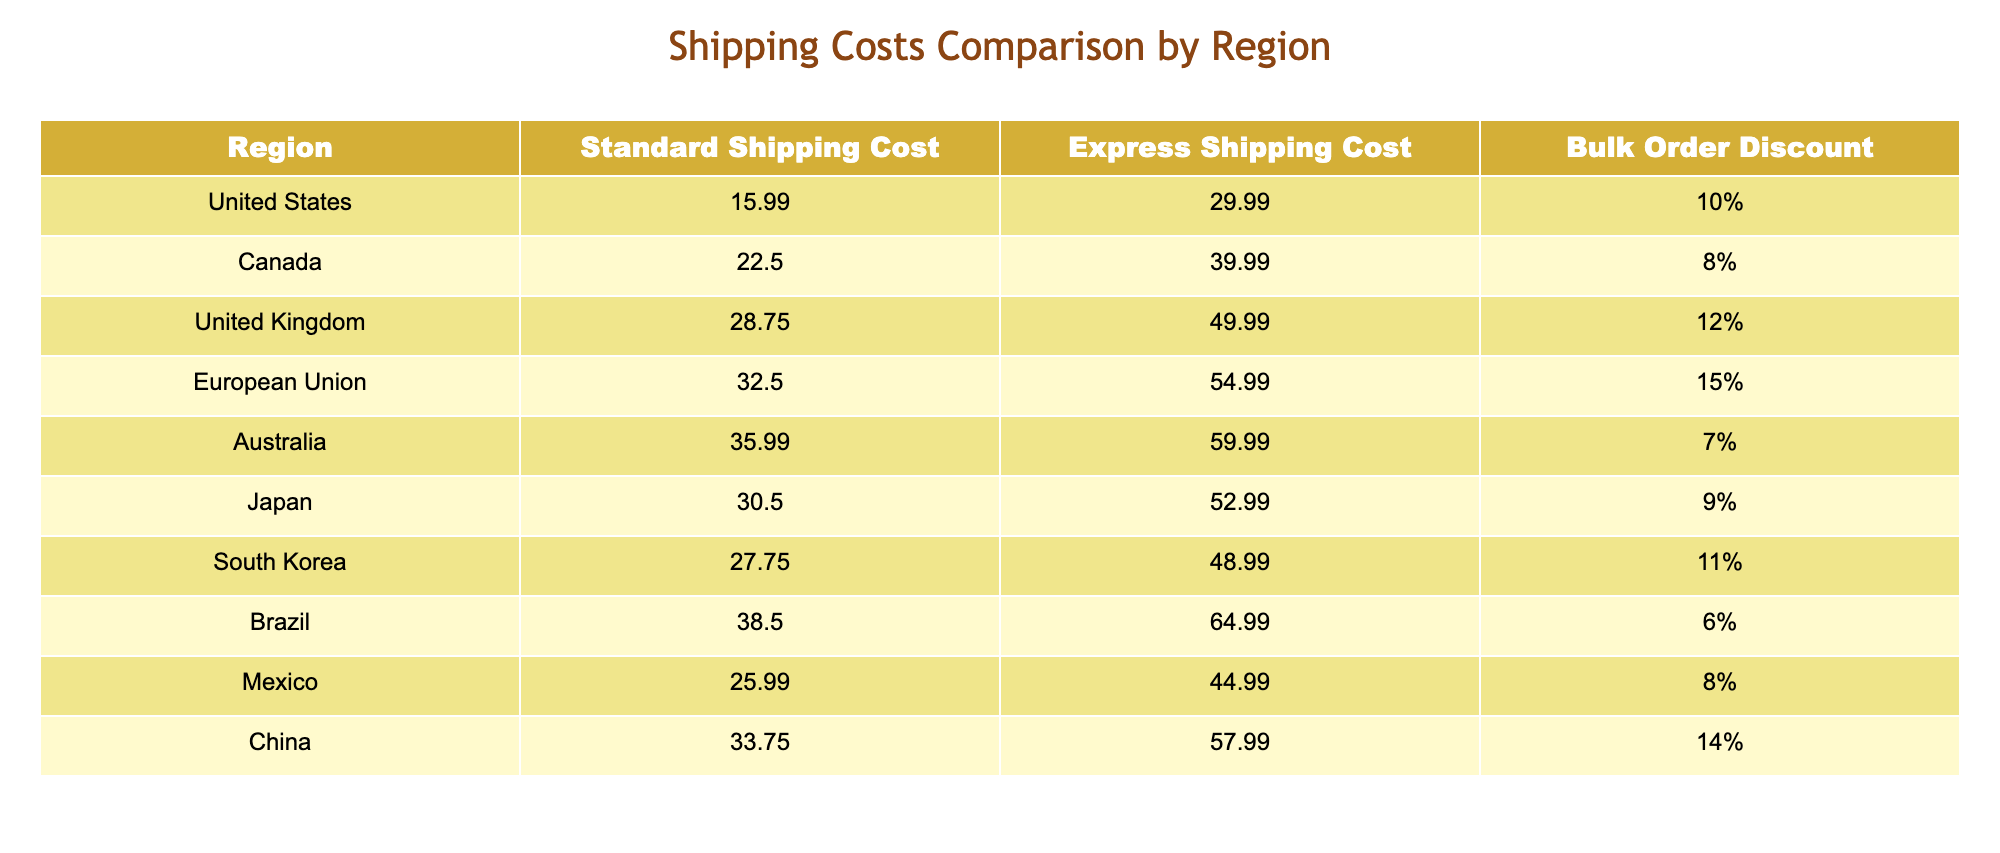What is the standard shipping cost to Canada? The table shows that the standard shipping cost to Canada is listed as 22.50.
Answer: 22.50 Which region has the highest express shipping cost? By comparing the express shipping costs across all listed regions in the table, Brazil has the highest cost at 64.99.
Answer: Brazil What is the bulk order discount percentage for the European Union? The table states that the bulk order discount for the European Union is 15%.
Answer: 15% If I order martial arts equipment to Australia, how much more would I pay for express shipping compared to standard shipping? For Australia, standard shipping is 35.99 and express is 59.99. The difference is calculated as 59.99 - 35.99 = 24.00.
Answer: 24.00 Is the bulk order discount higher for the United Kingdom than for Japan? The bulk order discount for the United Kingdom is 12% while for Japan it is 9%. Since 12% is greater than 9%, the answer is yes.
Answer: Yes What is the average standard shipping cost across all regions listed? To find the average, sum up the standard shipping costs: 15.99 + 22.50 + 28.75 + 32.50 + 35.99 + 30.50 + 27.75 + 38.50 + 25.99 + 33.75 =  319.27. Then divide by the number of regions (10): 319.27 / 10 = 31.93.
Answer: 31.93 Which costs more on average: standard shipping or express shipping? To compare averages, calculate the average standard shipping cost as (319.27 / 10 = 31.93), and the average express shipping cost by summing express shipping costs: 29.99 + 39.99 + 49.99 + 54.99 + 59.99 + 52.99 + 48.99 + 64.99 + 44.99 + 57.99 = 499.90, and then divide by 10: 499.90 / 10 = 49.99. Since 49.99 is greater than 31.93, express shipping costs more on average.
Answer: Express shipping Are there any regions with a bulk order discount of less than 8%? Looking at the table, the regions with bulk order discounts are: United States (10%), Canada (8%), United Kingdom (12%), European Union (15%), Australia (7%), Japan (9%), South Korea (11%), Brazil (6%), Mexico (8%), China (14%). The regions Brazil and Australia have bulk order discounts below 8%, thus the answer is yes.
Answer: Yes 